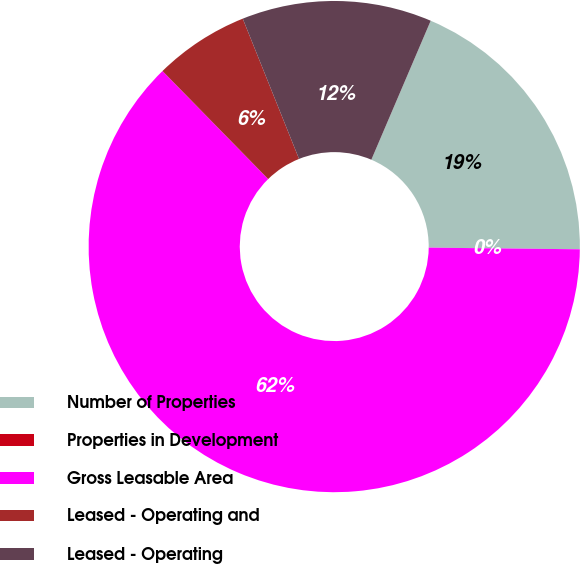Convert chart to OTSL. <chart><loc_0><loc_0><loc_500><loc_500><pie_chart><fcel>Number of Properties<fcel>Properties in Development<fcel>Gross Leasable Area<fcel>Leased - Operating and<fcel>Leased - Operating<nl><fcel>18.75%<fcel>0.0%<fcel>62.5%<fcel>6.25%<fcel>12.5%<nl></chart> 